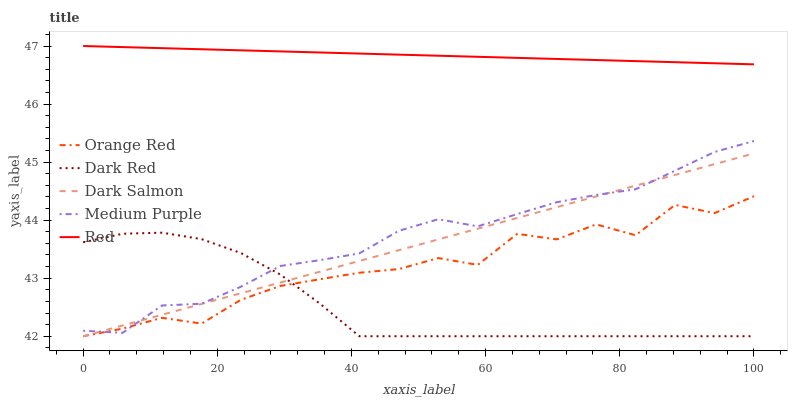Does Orange Red have the minimum area under the curve?
Answer yes or no. No. Does Orange Red have the maximum area under the curve?
Answer yes or no. No. Is Dark Red the smoothest?
Answer yes or no. No. Is Dark Red the roughest?
Answer yes or no. No. Does Red have the lowest value?
Answer yes or no. No. Does Orange Red have the highest value?
Answer yes or no. No. Is Dark Salmon less than Red?
Answer yes or no. Yes. Is Red greater than Orange Red?
Answer yes or no. Yes. Does Dark Salmon intersect Red?
Answer yes or no. No. 